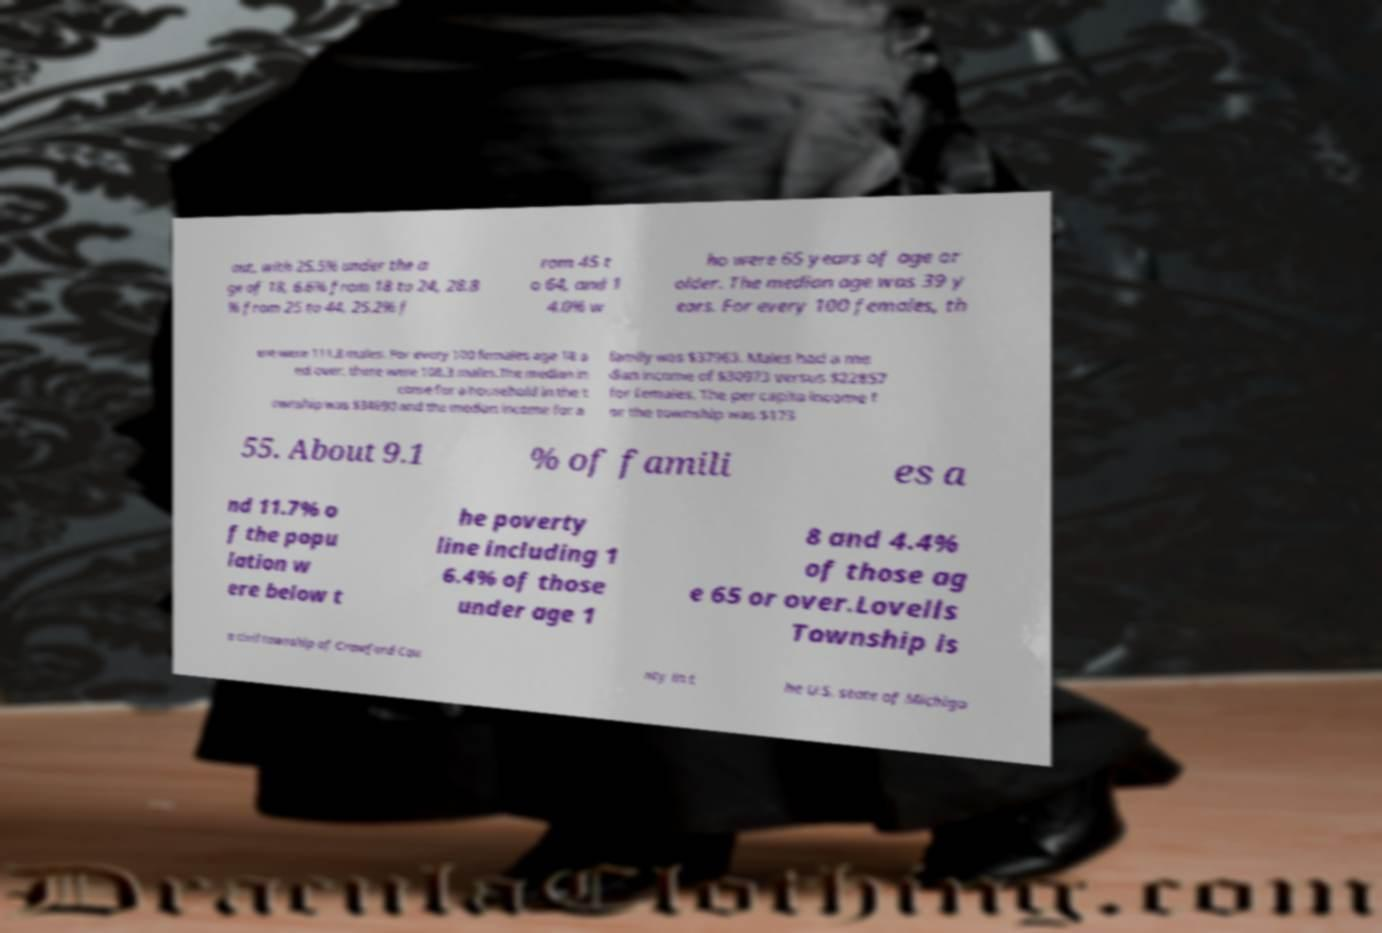Can you accurately transcribe the text from the provided image for me? out, with 25.5% under the a ge of 18, 6.6% from 18 to 24, 28.8 % from 25 to 44, 25.2% f rom 45 t o 64, and 1 4.0% w ho were 65 years of age or older. The median age was 39 y ears. For every 100 females, th ere were 111.8 males. For every 100 females age 18 a nd over, there were 108.3 males.The median in come for a household in the t ownship was $34690 and the median income for a family was $37963. Males had a me dian income of $30973 versus $22857 for females. The per capita income f or the township was $173 55. About 9.1 % of famili es a nd 11.7% o f the popu lation w ere below t he poverty line including 1 6.4% of those under age 1 8 and 4.4% of those ag e 65 or over.Lovells Township is a civil township of Crawford Cou nty in t he U.S. state of Michiga 